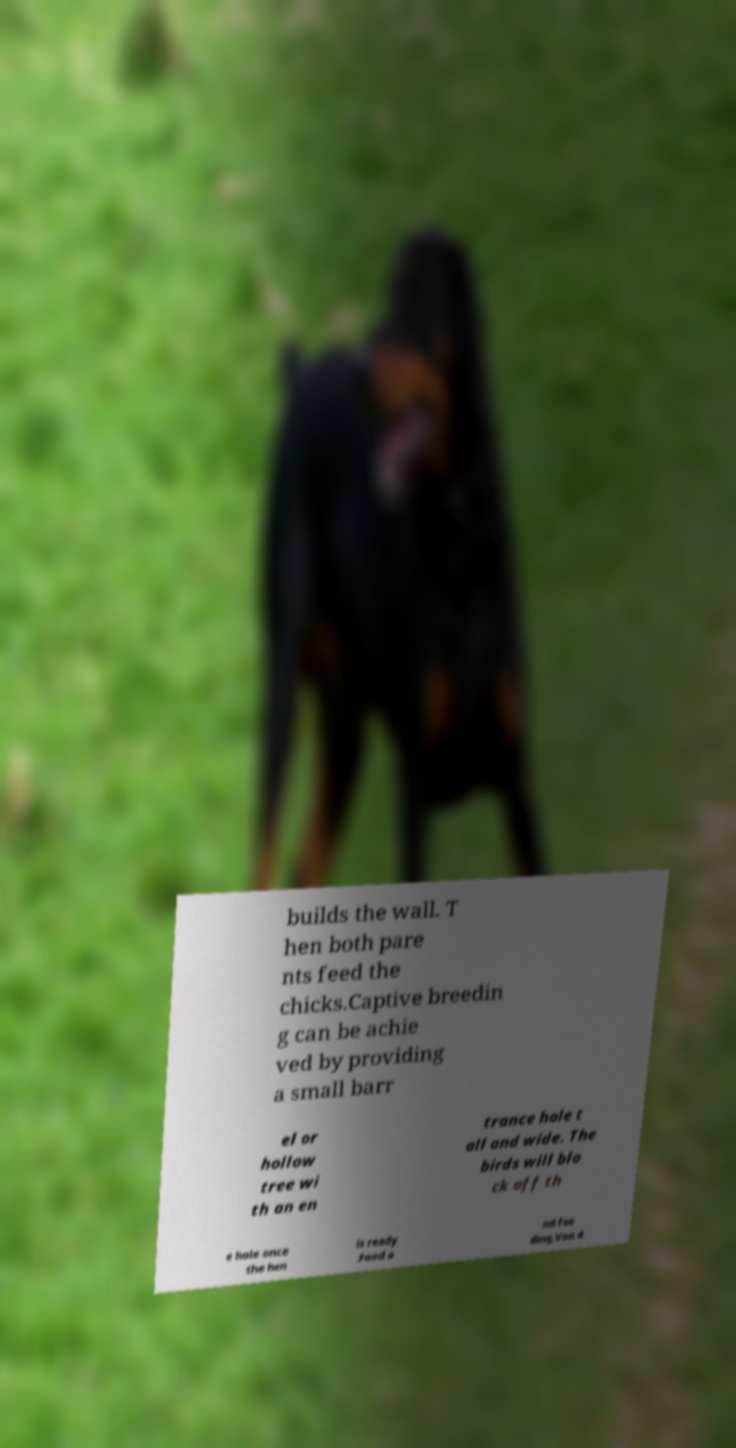For documentation purposes, I need the text within this image transcribed. Could you provide that? builds the wall. T hen both pare nts feed the chicks.Captive breedin g can be achie ved by providing a small barr el or hollow tree wi th an en trance hole t all and wide. The birds will blo ck off th e hole once the hen is ready .Food a nd fee ding.Von d 